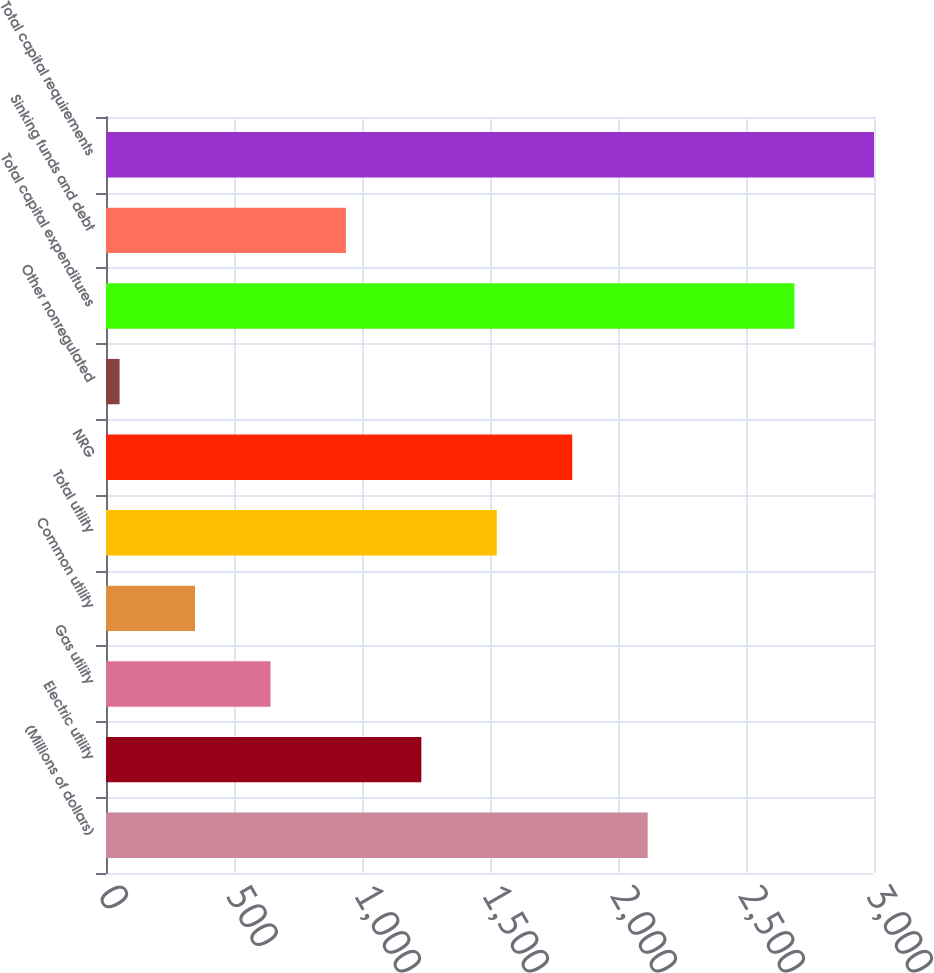<chart> <loc_0><loc_0><loc_500><loc_500><bar_chart><fcel>(Millions of dollars)<fcel>Electric utility<fcel>Gas utility<fcel>Common utility<fcel>Total utility<fcel>NRG<fcel>Other nonregulated<fcel>Total capital expenditures<fcel>Sinking funds and debt<fcel>Total capital requirements<nl><fcel>2115.9<fcel>1231.8<fcel>642.4<fcel>347.7<fcel>1526.5<fcel>1821.2<fcel>53<fcel>2689<fcel>937.1<fcel>3000<nl></chart> 